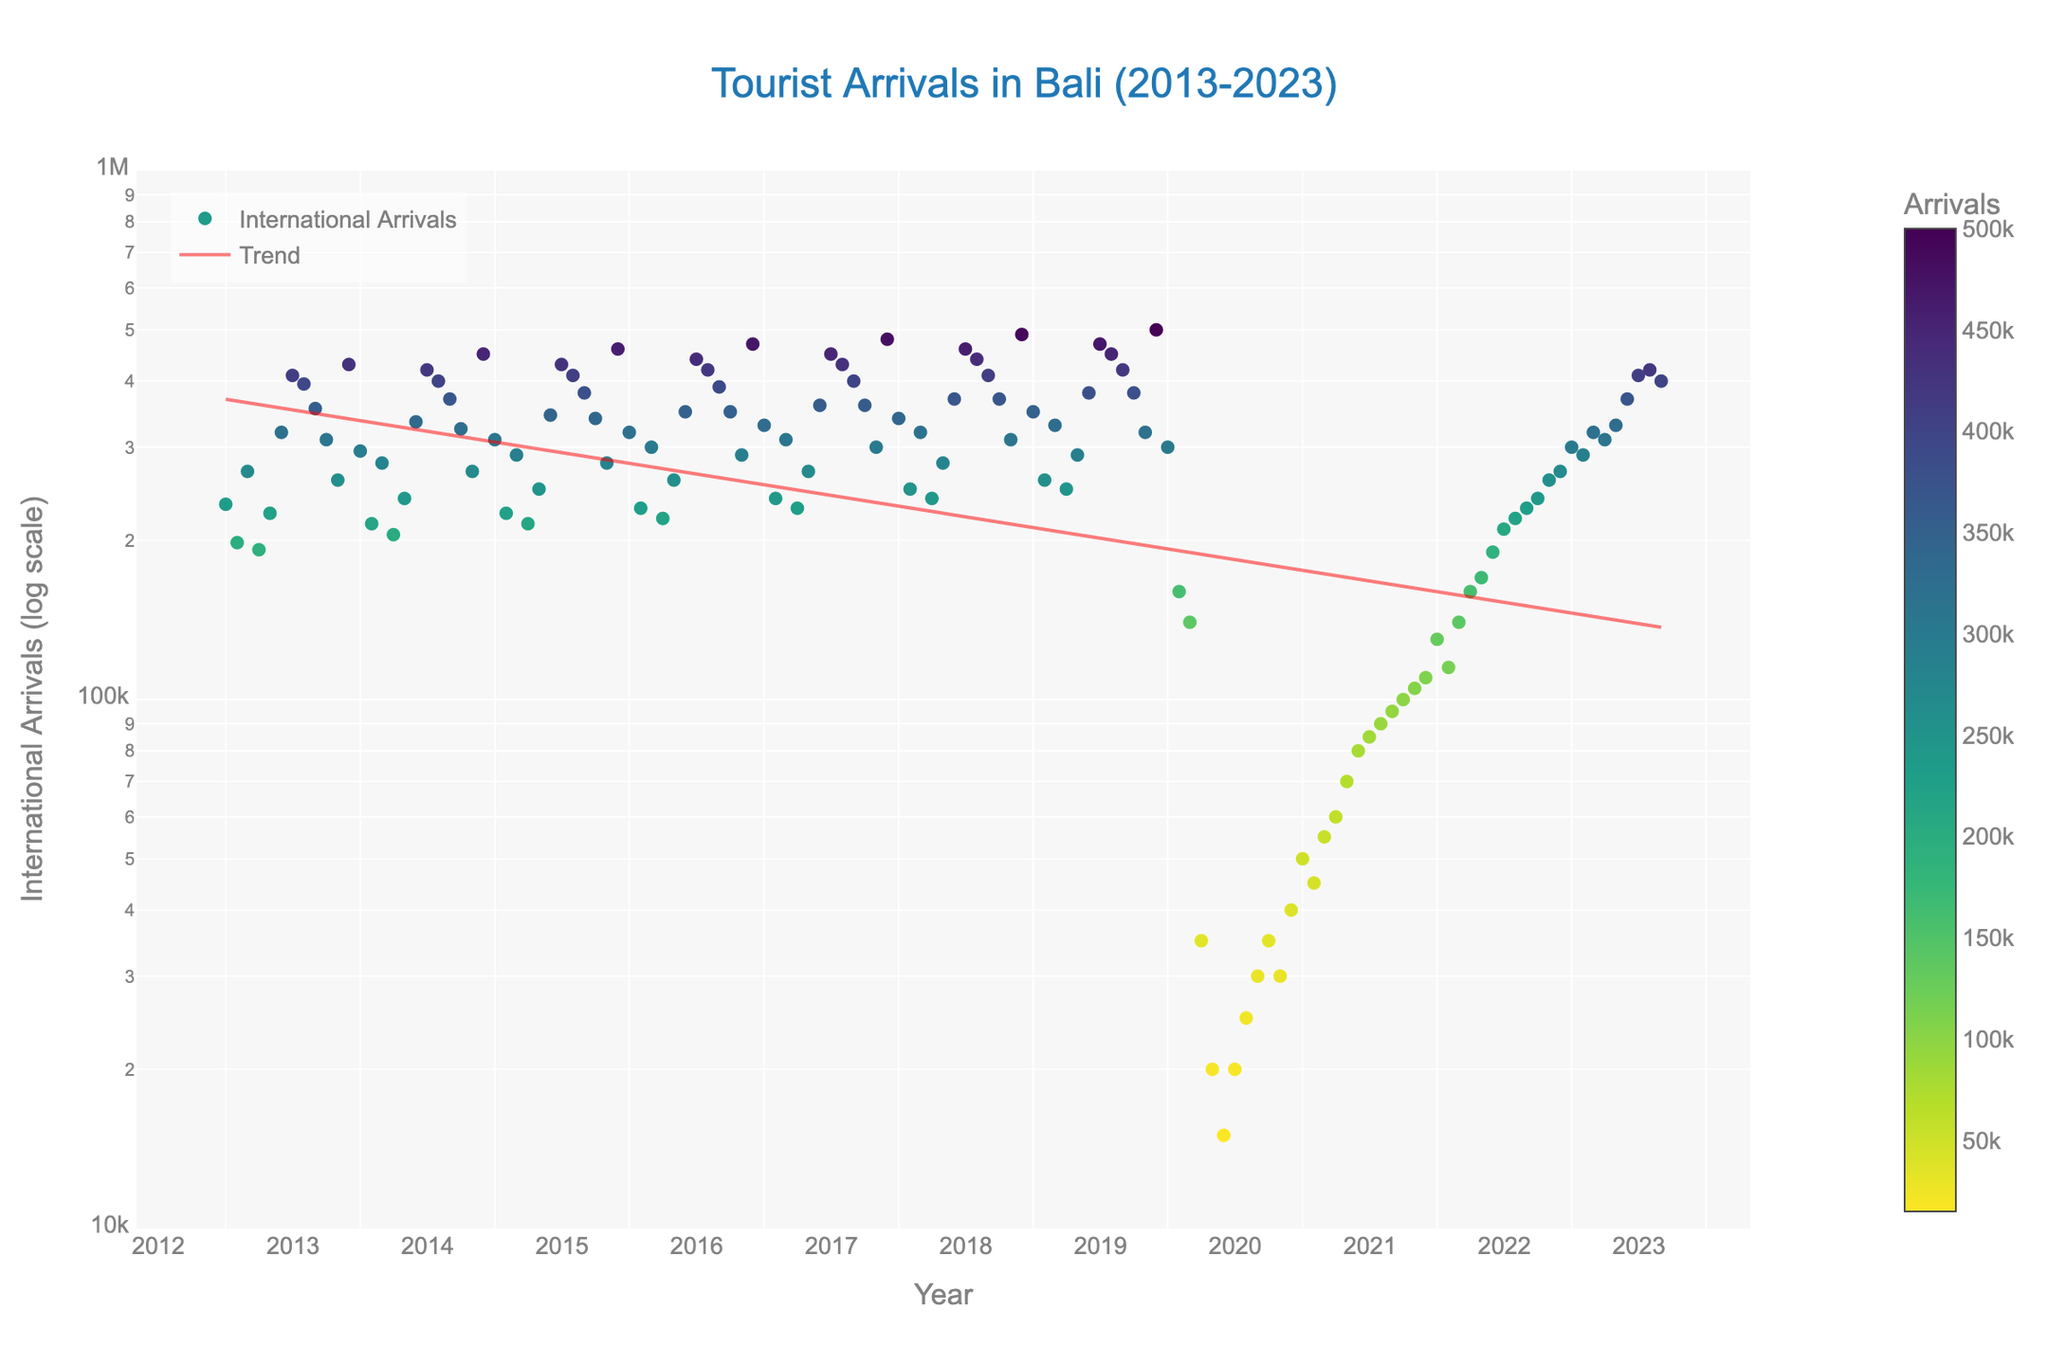What is the title of the scatter plot? The scatter plot's title is provided in the figure layout, displayed prominently at the top-center of the plot. The title describes the main subject of the plot.
Answer: Tourist Arrivals in Bali (2013-2023) What do the points on the scatter plot represent? Each point on the scatter plot corresponds to the number of international arrivals to Bali for a particular month and year. These are depicted against a log scale on the y-axis.
Answer: International Arrivals How is the data trend over time visualized in the scatter plot? The trend line, which is a fitted curve, helps visualize how the number of international arrivals changes over time. It accounts for the log scale on the y-axis to better represent exponential growth or decline.
Answer: Through a fitted trend line Which month and year has the highest number of international arrivals according to the plot? By finding the highest point on the scatter plot, one can identify the corresponding month and year. The color intensity also assists in visual confirmation.
Answer: December 2019 How do the tourist arrivals in July 2017 compare to those in July 2020? To compare, find the points corresponding to July 2017 and July 2020 on the scatter plot. Notice the difference in their positions and the number of arrivals indicated.
Answer: July 2017 had much higher arrivals than July 2020 What significant trend do you observe for the year 2020? The trend can be observed by noting the steep drop in points during 2020 compared to previous years and the subsequent months, indicating a significant decrease in tourist arrivals.
Answer: Significant drop in arrivals From 2013 to 2023, which years show a clear seasonal trend in tourist arrivals? Look for consistent patterns in the ups and downs of the points for each year, especially notable peaks and troughs in similar months across different years.
Answer: Most years except 2020 show a clear seasonal trend In which year do tourist arrivals begin to recover after the sharp drop in 2020? By examining the points after the lowest values in 2020, one can see the starting point of the recovery trend in subsequent years.
Answer: 2021 What does the color intensity of the points indicate? The colorscale is used to represent the magnitude of international arrivals. Brighter or more intense colors correspond to higher numbers of arrivals.
Answer: The number of international arrivals Is there any month consistently having fewer arrivals over the decade? By observing the peaks and troughs for consistency, analyze which month(s) usually have fewer arrivals depicted across different years.
Answer: February 